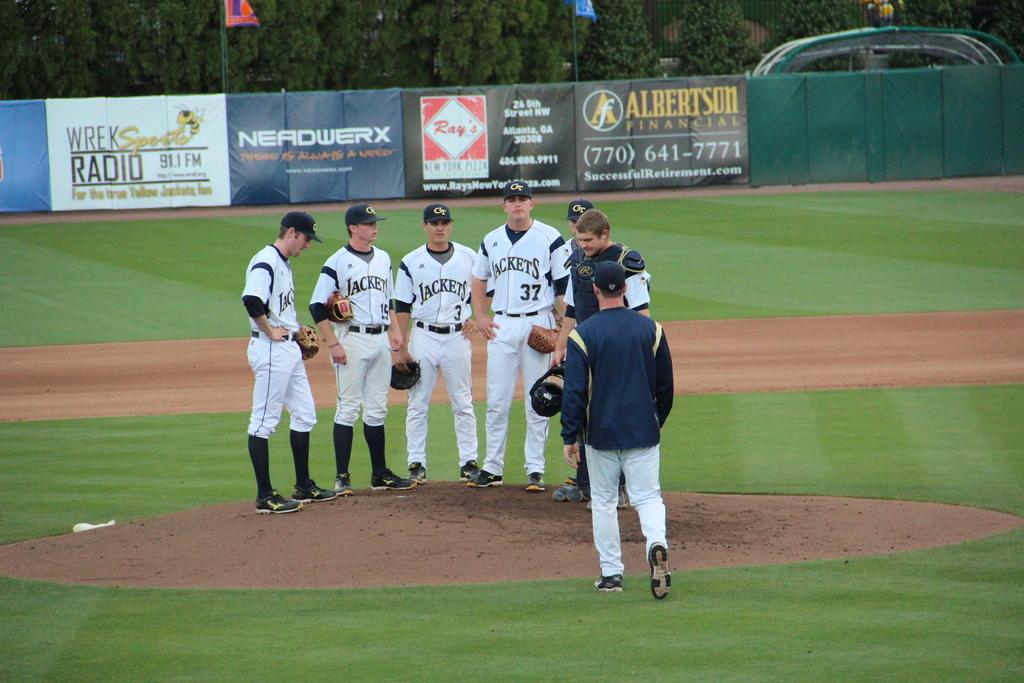<image>
Share a concise interpretation of the image provided. The Jackets baseball team players stood on the mound in front of a Nerdwerx sign, which is next to a 91.1 FM radio sign. 